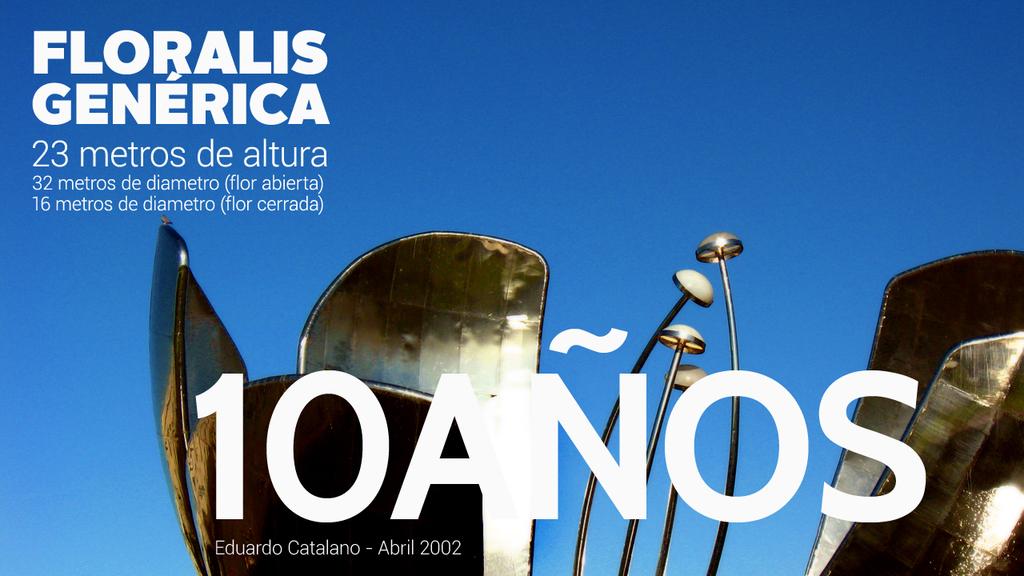How many years?
Provide a succinct answer. 10. What number is listed?
Your response must be concise. 10. 